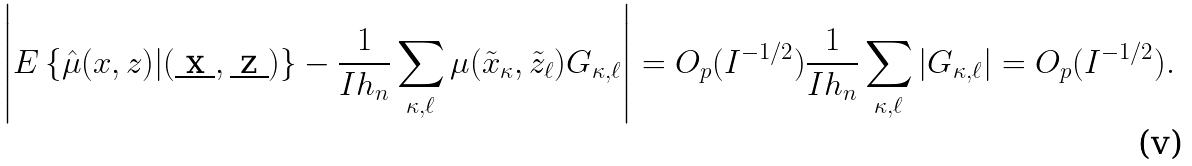Convert formula to latex. <formula><loc_0><loc_0><loc_500><loc_500>\left | E \left \{ \hat { \mu } ( x , z ) | ( \underbar { x } , \underbar { z } ) \right \} - \frac { 1 } { I h _ { n } } \sum _ { \kappa , \ell } \mu ( \tilde { x } _ { \kappa } , \tilde { z } _ { \ell } ) G _ { \kappa , \ell } \right | = O _ { p } ( I ^ { - 1 / 2 } ) \frac { 1 } { I h _ { n } } \sum _ { \kappa , \ell } | G _ { \kappa , \ell } | = O _ { p } ( I ^ { - 1 / 2 } ) .</formula> 